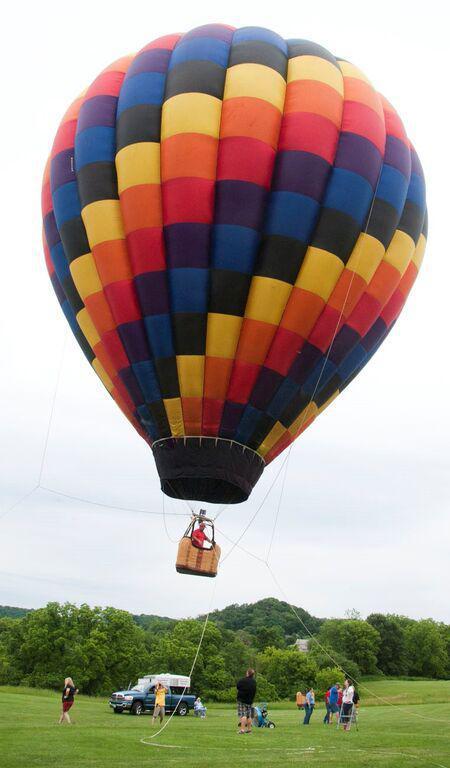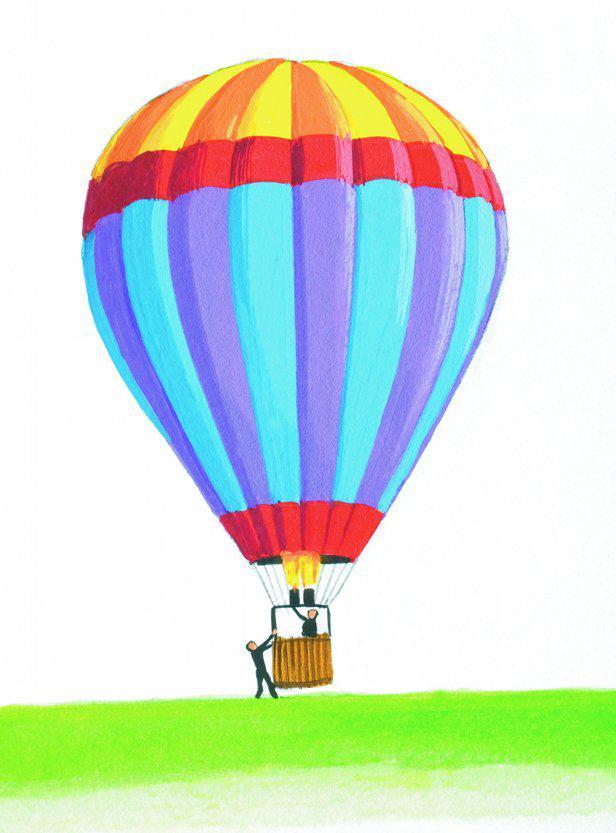The first image is the image on the left, the second image is the image on the right. Examine the images to the left and right. Is the description "Only one image in the pair contains a single balloon." accurate? Answer yes or no. No. The first image is the image on the left, the second image is the image on the right. Assess this claim about the two images: "One image contains at least 7 hot air balloons.". Correct or not? Answer yes or no. No. 